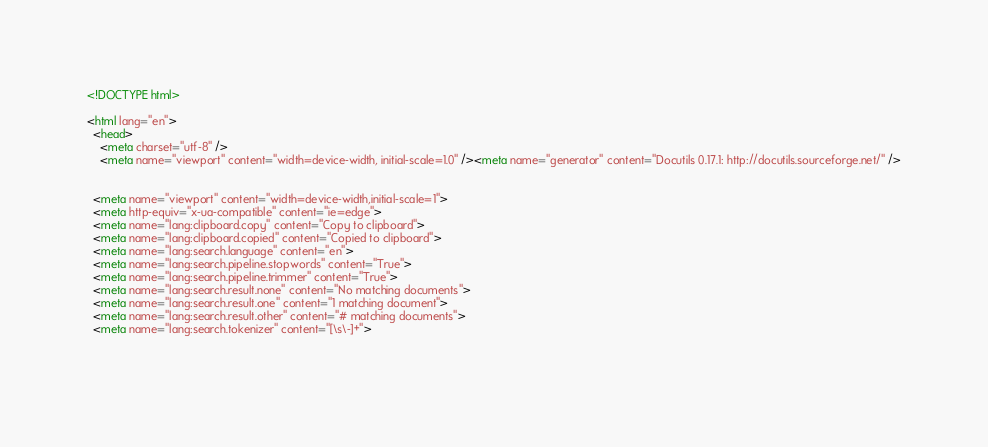<code> <loc_0><loc_0><loc_500><loc_500><_HTML_>

<!DOCTYPE html>

<html lang="en">
  <head>
    <meta charset="utf-8" />
    <meta name="viewport" content="width=device-width, initial-scale=1.0" /><meta name="generator" content="Docutils 0.17.1: http://docutils.sourceforge.net/" />

  
  <meta name="viewport" content="width=device-width,initial-scale=1">
  <meta http-equiv="x-ua-compatible" content="ie=edge">
  <meta name="lang:clipboard.copy" content="Copy to clipboard">
  <meta name="lang:clipboard.copied" content="Copied to clipboard">
  <meta name="lang:search.language" content="en">
  <meta name="lang:search.pipeline.stopwords" content="True">
  <meta name="lang:search.pipeline.trimmer" content="True">
  <meta name="lang:search.result.none" content="No matching documents">
  <meta name="lang:search.result.one" content="1 matching document">
  <meta name="lang:search.result.other" content="# matching documents">
  <meta name="lang:search.tokenizer" content="[\s\-]+">

  </code> 